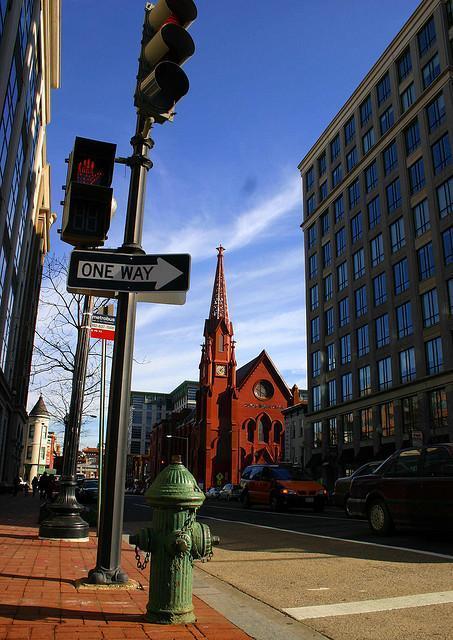How many orange traffic cones are in the photo?
Give a very brief answer. 0. How many stories is the building on the right?
Give a very brief answer. 10. How many colors is the fire hydrant?
Give a very brief answer. 1. How many cars can you see?
Give a very brief answer. 2. How many traffic lights are in the photo?
Give a very brief answer. 2. How many people on motorcycles are facing this way?
Give a very brief answer. 0. 